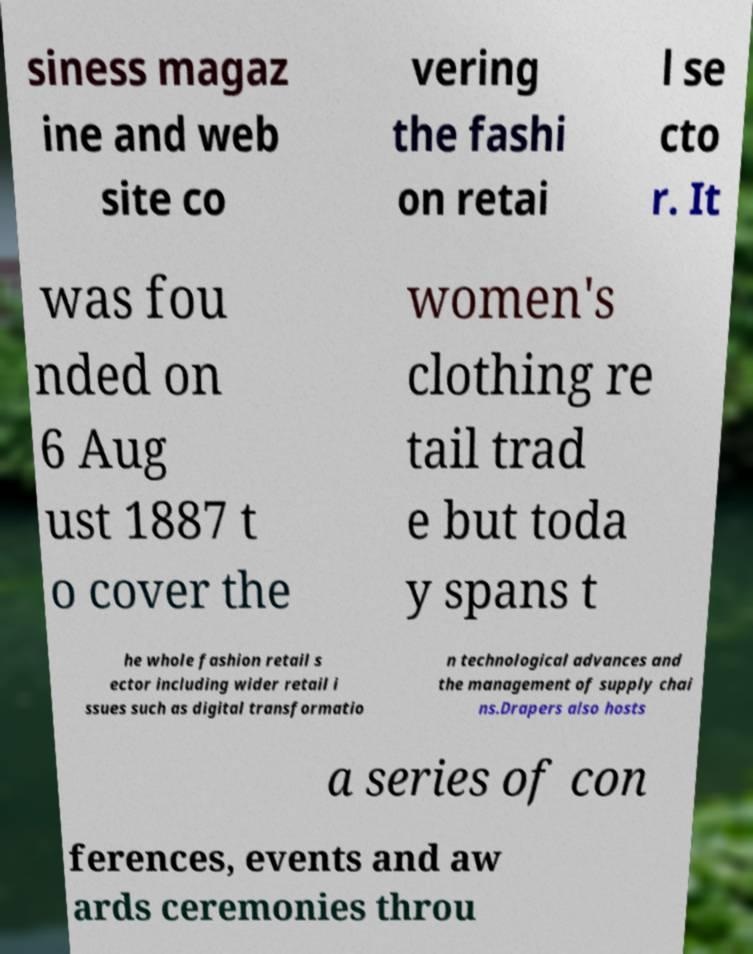I need the written content from this picture converted into text. Can you do that? siness magaz ine and web site co vering the fashi on retai l se cto r. It was fou nded on 6 Aug ust 1887 t o cover the women's clothing re tail trad e but toda y spans t he whole fashion retail s ector including wider retail i ssues such as digital transformatio n technological advances and the management of supply chai ns.Drapers also hosts a series of con ferences, events and aw ards ceremonies throu 